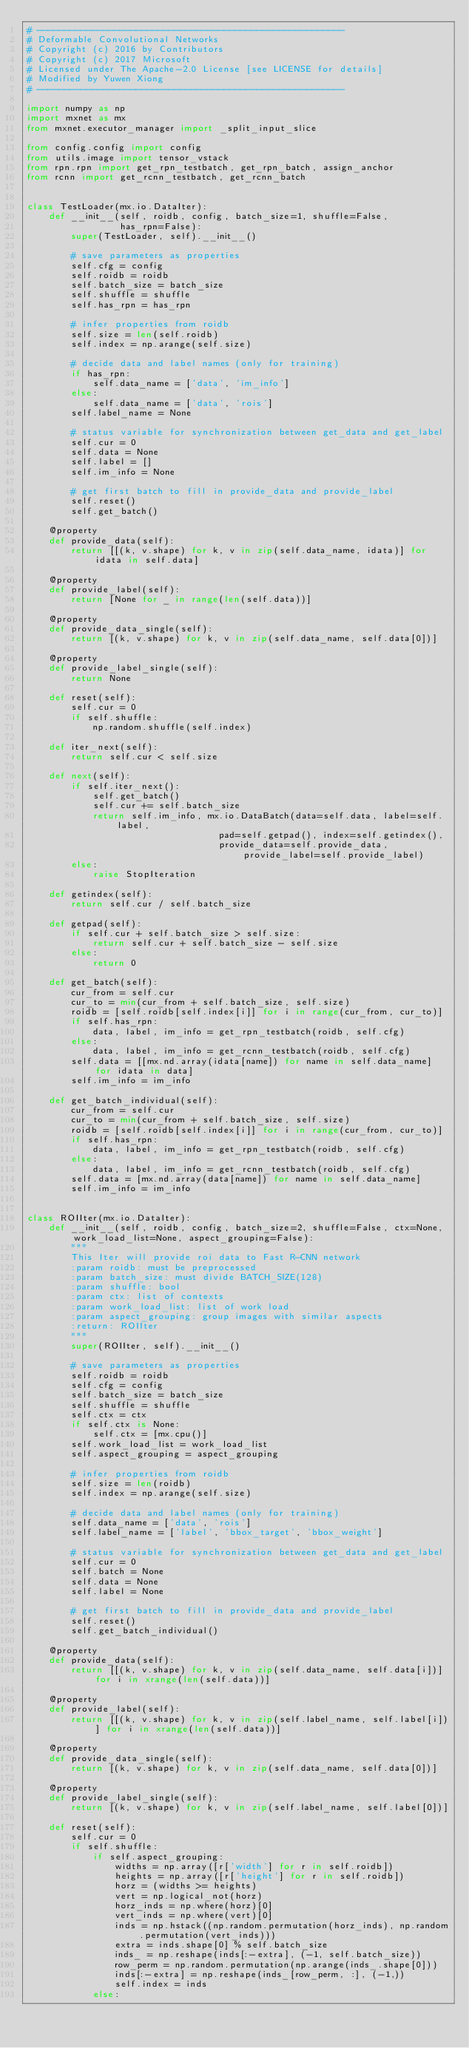<code> <loc_0><loc_0><loc_500><loc_500><_Python_># --------------------------------------------------------
# Deformable Convolutional Networks
# Copyright (c) 2016 by Contributors
# Copyright (c) 2017 Microsoft
# Licensed under The Apache-2.0 License [see LICENSE for details]
# Modified by Yuwen Xiong
# --------------------------------------------------------

import numpy as np
import mxnet as mx
from mxnet.executor_manager import _split_input_slice

from config.config import config
from utils.image import tensor_vstack
from rpn.rpn import get_rpn_testbatch, get_rpn_batch, assign_anchor
from rcnn import get_rcnn_testbatch, get_rcnn_batch


class TestLoader(mx.io.DataIter):
    def __init__(self, roidb, config, batch_size=1, shuffle=False,
                 has_rpn=False):
        super(TestLoader, self).__init__()

        # save parameters as properties
        self.cfg = config
        self.roidb = roidb
        self.batch_size = batch_size
        self.shuffle = shuffle
        self.has_rpn = has_rpn

        # infer properties from roidb
        self.size = len(self.roidb)
        self.index = np.arange(self.size)

        # decide data and label names (only for training)
        if has_rpn:
            self.data_name = ['data', 'im_info']
        else:
            self.data_name = ['data', 'rois']
        self.label_name = None

        # status variable for synchronization between get_data and get_label
        self.cur = 0
        self.data = None
        self.label = []
        self.im_info = None

        # get first batch to fill in provide_data and provide_label
        self.reset()
        self.get_batch()

    @property
    def provide_data(self):
        return [[(k, v.shape) for k, v in zip(self.data_name, idata)] for idata in self.data]

    @property
    def provide_label(self):
        return [None for _ in range(len(self.data))]

    @property
    def provide_data_single(self):
        return [(k, v.shape) for k, v in zip(self.data_name, self.data[0])]

    @property
    def provide_label_single(self):
        return None

    def reset(self):
        self.cur = 0
        if self.shuffle:
            np.random.shuffle(self.index)

    def iter_next(self):
        return self.cur < self.size

    def next(self):
        if self.iter_next():
            self.get_batch()
            self.cur += self.batch_size
            return self.im_info, mx.io.DataBatch(data=self.data, label=self.label,
                                   pad=self.getpad(), index=self.getindex(),
                                   provide_data=self.provide_data, provide_label=self.provide_label)
        else:
            raise StopIteration

    def getindex(self):
        return self.cur / self.batch_size

    def getpad(self):
        if self.cur + self.batch_size > self.size:
            return self.cur + self.batch_size - self.size
        else:
            return 0

    def get_batch(self):
        cur_from = self.cur
        cur_to = min(cur_from + self.batch_size, self.size)
        roidb = [self.roidb[self.index[i]] for i in range(cur_from, cur_to)]
        if self.has_rpn:
            data, label, im_info = get_rpn_testbatch(roidb, self.cfg)
        else:
            data, label, im_info = get_rcnn_testbatch(roidb, self.cfg)
        self.data = [[mx.nd.array(idata[name]) for name in self.data_name] for idata in data]
        self.im_info = im_info

    def get_batch_individual(self):
        cur_from = self.cur
        cur_to = min(cur_from + self.batch_size, self.size)
        roidb = [self.roidb[self.index[i]] for i in range(cur_from, cur_to)]
        if self.has_rpn:
            data, label, im_info = get_rpn_testbatch(roidb, self.cfg)
        else:
            data, label, im_info = get_rcnn_testbatch(roidb, self.cfg)
        self.data = [mx.nd.array(data[name]) for name in self.data_name]
        self.im_info = im_info


class ROIIter(mx.io.DataIter):
    def __init__(self, roidb, config, batch_size=2, shuffle=False, ctx=None, work_load_list=None, aspect_grouping=False):
        """
        This Iter will provide roi data to Fast R-CNN network
        :param roidb: must be preprocessed
        :param batch_size: must divide BATCH_SIZE(128)
        :param shuffle: bool
        :param ctx: list of contexts
        :param work_load_list: list of work load
        :param aspect_grouping: group images with similar aspects
        :return: ROIIter
        """
        super(ROIIter, self).__init__()

        # save parameters as properties
        self.roidb = roidb
        self.cfg = config
        self.batch_size = batch_size
        self.shuffle = shuffle
        self.ctx = ctx
        if self.ctx is None:
            self.ctx = [mx.cpu()]
        self.work_load_list = work_load_list
        self.aspect_grouping = aspect_grouping

        # infer properties from roidb
        self.size = len(roidb)
        self.index = np.arange(self.size)

        # decide data and label names (only for training)
        self.data_name = ['data', 'rois']
        self.label_name = ['label', 'bbox_target', 'bbox_weight']

        # status variable for synchronization between get_data and get_label
        self.cur = 0
        self.batch = None
        self.data = None
        self.label = None

        # get first batch to fill in provide_data and provide_label
        self.reset()
        self.get_batch_individual()

    @property
    def provide_data(self):
        return [[(k, v.shape) for k, v in zip(self.data_name, self.data[i])] for i in xrange(len(self.data))]

    @property
    def provide_label(self):
        return [[(k, v.shape) for k, v in zip(self.label_name, self.label[i])] for i in xrange(len(self.data))]

    @property
    def provide_data_single(self):
        return [(k, v.shape) for k, v in zip(self.data_name, self.data[0])]

    @property
    def provide_label_single(self):
        return [(k, v.shape) for k, v in zip(self.label_name, self.label[0])]

    def reset(self):
        self.cur = 0
        if self.shuffle:
            if self.aspect_grouping:
                widths = np.array([r['width'] for r in self.roidb])
                heights = np.array([r['height'] for r in self.roidb])
                horz = (widths >= heights)
                vert = np.logical_not(horz)
                horz_inds = np.where(horz)[0]
                vert_inds = np.where(vert)[0]
                inds = np.hstack((np.random.permutation(horz_inds), np.random.permutation(vert_inds)))
                extra = inds.shape[0] % self.batch_size
                inds_ = np.reshape(inds[:-extra], (-1, self.batch_size))
                row_perm = np.random.permutation(np.arange(inds_.shape[0]))
                inds[:-extra] = np.reshape(inds_[row_perm, :], (-1,))
                self.index = inds
            else:</code> 